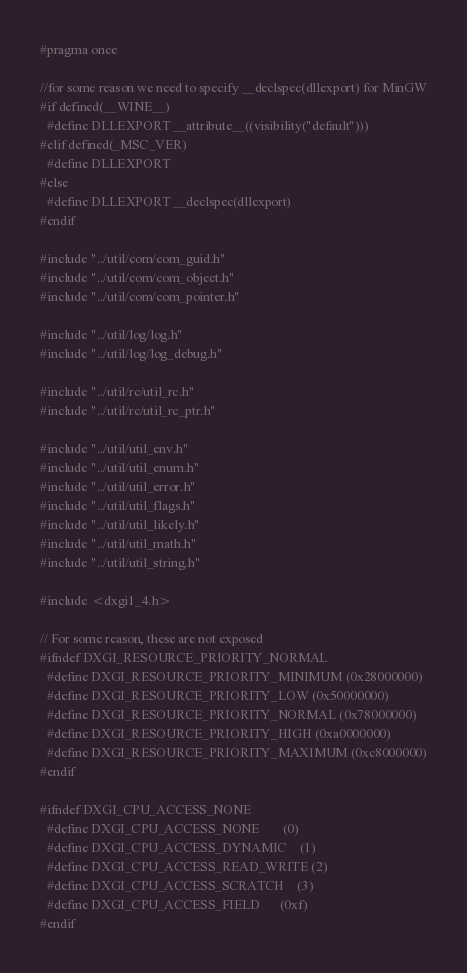Convert code to text. <code><loc_0><loc_0><loc_500><loc_500><_C_>#pragma once

//for some reason we need to specify __declspec(dllexport) for MinGW
#if defined(__WINE__)
  #define DLLEXPORT __attribute__((visibility("default")))
#elif defined(_MSC_VER)
  #define DLLEXPORT
#else
  #define DLLEXPORT __declspec(dllexport)
#endif

#include "../util/com/com_guid.h"
#include "../util/com/com_object.h"
#include "../util/com/com_pointer.h"

#include "../util/log/log.h"
#include "../util/log/log_debug.h"

#include "../util/rc/util_rc.h"
#include "../util/rc/util_rc_ptr.h"

#include "../util/util_env.h"
#include "../util/util_enum.h"
#include "../util/util_error.h"
#include "../util/util_flags.h"
#include "../util/util_likely.h"
#include "../util/util_math.h"
#include "../util/util_string.h"

#include <dxgi1_4.h>

// For some reason, these are not exposed
#ifndef DXGI_RESOURCE_PRIORITY_NORMAL
  #define DXGI_RESOURCE_PRIORITY_MINIMUM (0x28000000)
  #define DXGI_RESOURCE_PRIORITY_LOW (0x50000000)
  #define DXGI_RESOURCE_PRIORITY_NORMAL (0x78000000)
  #define DXGI_RESOURCE_PRIORITY_HIGH (0xa0000000)
  #define DXGI_RESOURCE_PRIORITY_MAXIMUM (0xc8000000)
#endif

#ifndef DXGI_CPU_ACCESS_NONE
  #define DXGI_CPU_ACCESS_NONE       (0)
  #define DXGI_CPU_ACCESS_DYNAMIC    (1)
  #define DXGI_CPU_ACCESS_READ_WRITE (2)
  #define DXGI_CPU_ACCESS_SCRATCH    (3)
  #define DXGI_CPU_ACCESS_FIELD      (0xf)
#endif</code> 